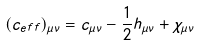Convert formula to latex. <formula><loc_0><loc_0><loc_500><loc_500>( { c _ { e f f } } ) _ { \mu \nu } = c _ { \mu \nu } - \frac { 1 } { 2 } h _ { \mu \nu } + { \chi } _ { \mu \nu }</formula> 